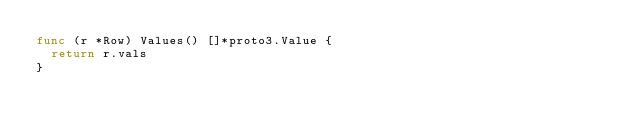Convert code to text. <code><loc_0><loc_0><loc_500><loc_500><_Go_>func (r *Row) Values() []*proto3.Value {
	return r.vals
}
</code> 